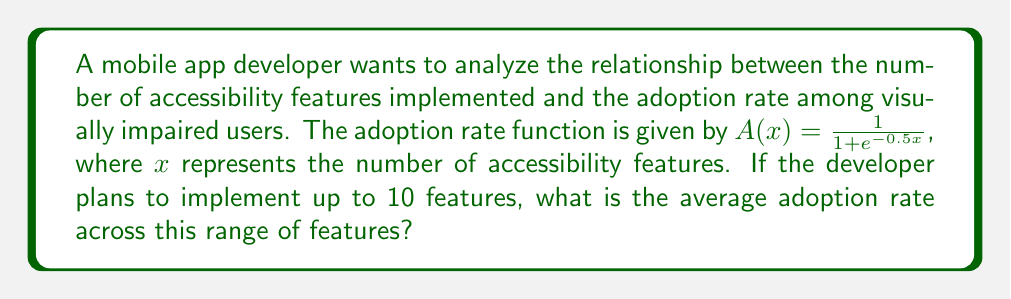Help me with this question. To solve this problem, we need to use integral calculus to find the average adoption rate. The steps are as follows:

1) The average value of a function $f(x)$ over an interval $[a,b]$ is given by:

   $$\frac{1}{b-a}\int_a^b f(x)dx$$

2) In our case, $a=0$, $b=10$, and $f(x) = A(x) = \frac{1}{1 + e^{-0.5x}}$

3) Substituting these values, we get:

   $$\text{Average Adoption Rate} = \frac{1}{10-0}\int_0^{10} \frac{1}{1 + e^{-0.5x}}dx$$

4) This integral doesn't have an elementary antiderivative, so we need to use numerical integration. We can use the trapezoidal rule with a small step size for a good approximation.

5) Let's use a step size of 0.1. We calculate the function value at each point:

   $A(0) = 0.5$
   $A(1) \approx 0.6225$
   $A(2) \approx 0.7311$
   ...
   $A(9) \approx 0.9526$
   $A(10) \approx 0.9665$

6) Applying the trapezoidal rule:

   $$\text{Average} \approx \frac{0.1}{2}(0.5 + 2(0.6225 + 0.7311 + ... + 0.9526) + 0.9665)$$

7) Calculating this sum gives us approximately 0.7986.
Answer: 0.7986 